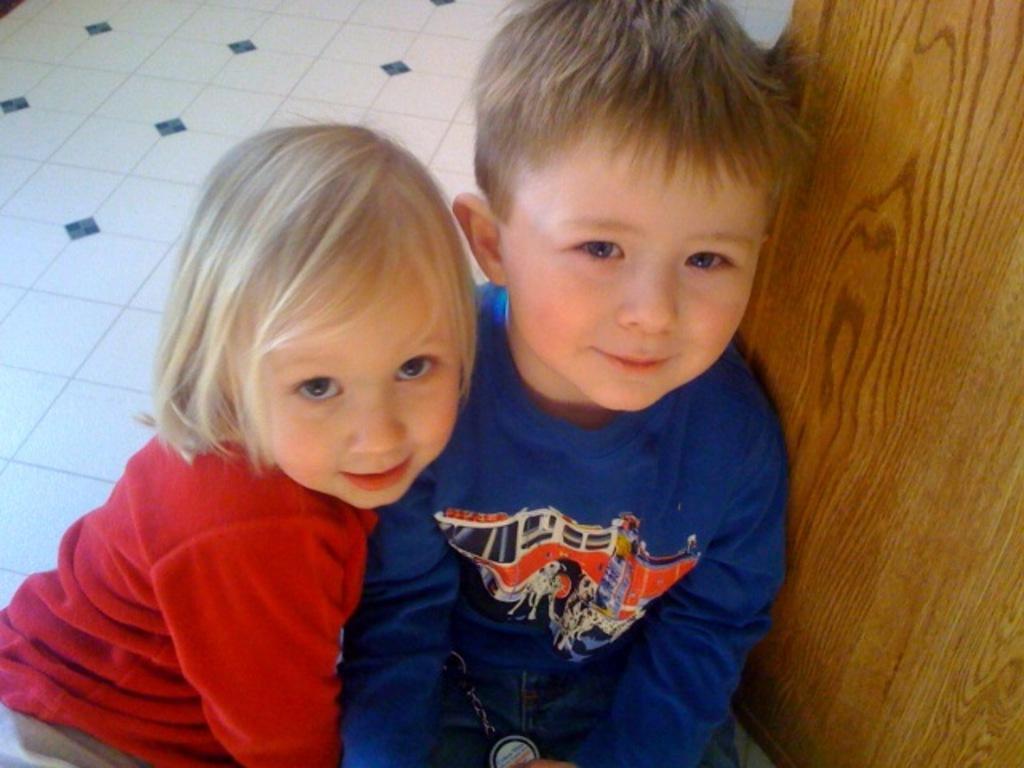Could you give a brief overview of what you see in this image? In this image we can see there are two persons sitting on the floor and at the side we can see the wooden object. 